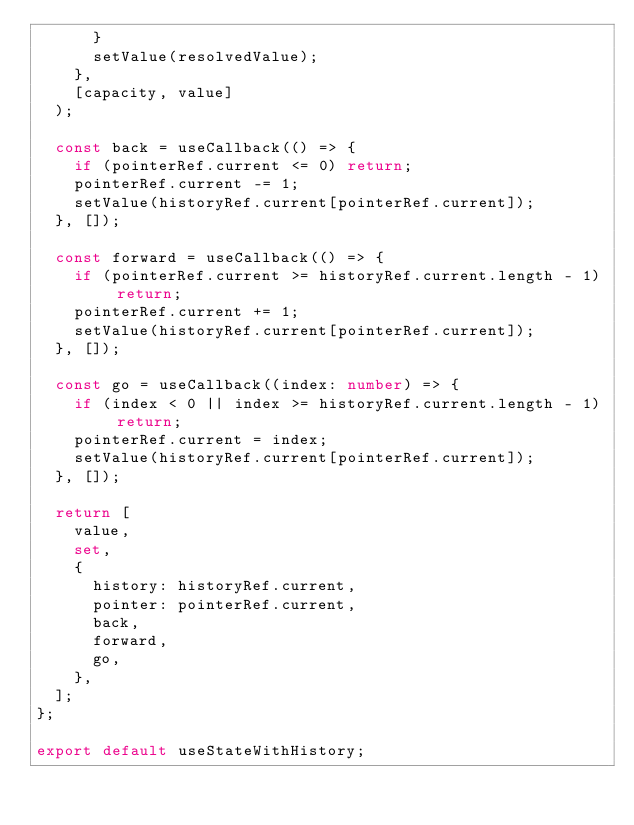<code> <loc_0><loc_0><loc_500><loc_500><_TypeScript_>      }
      setValue(resolvedValue);
    },
    [capacity, value]
  );

  const back = useCallback(() => {
    if (pointerRef.current <= 0) return;
    pointerRef.current -= 1;
    setValue(historyRef.current[pointerRef.current]);
  }, []);

  const forward = useCallback(() => {
    if (pointerRef.current >= historyRef.current.length - 1) return;
    pointerRef.current += 1;
    setValue(historyRef.current[pointerRef.current]);
  }, []);

  const go = useCallback((index: number) => {
    if (index < 0 || index >= historyRef.current.length - 1) return;
    pointerRef.current = index;
    setValue(historyRef.current[pointerRef.current]);
  }, []);

  return [
    value,
    set,
    {
      history: historyRef.current,
      pointer: pointerRef.current,
      back,
      forward,
      go,
    },
  ];
};

export default useStateWithHistory;
</code> 